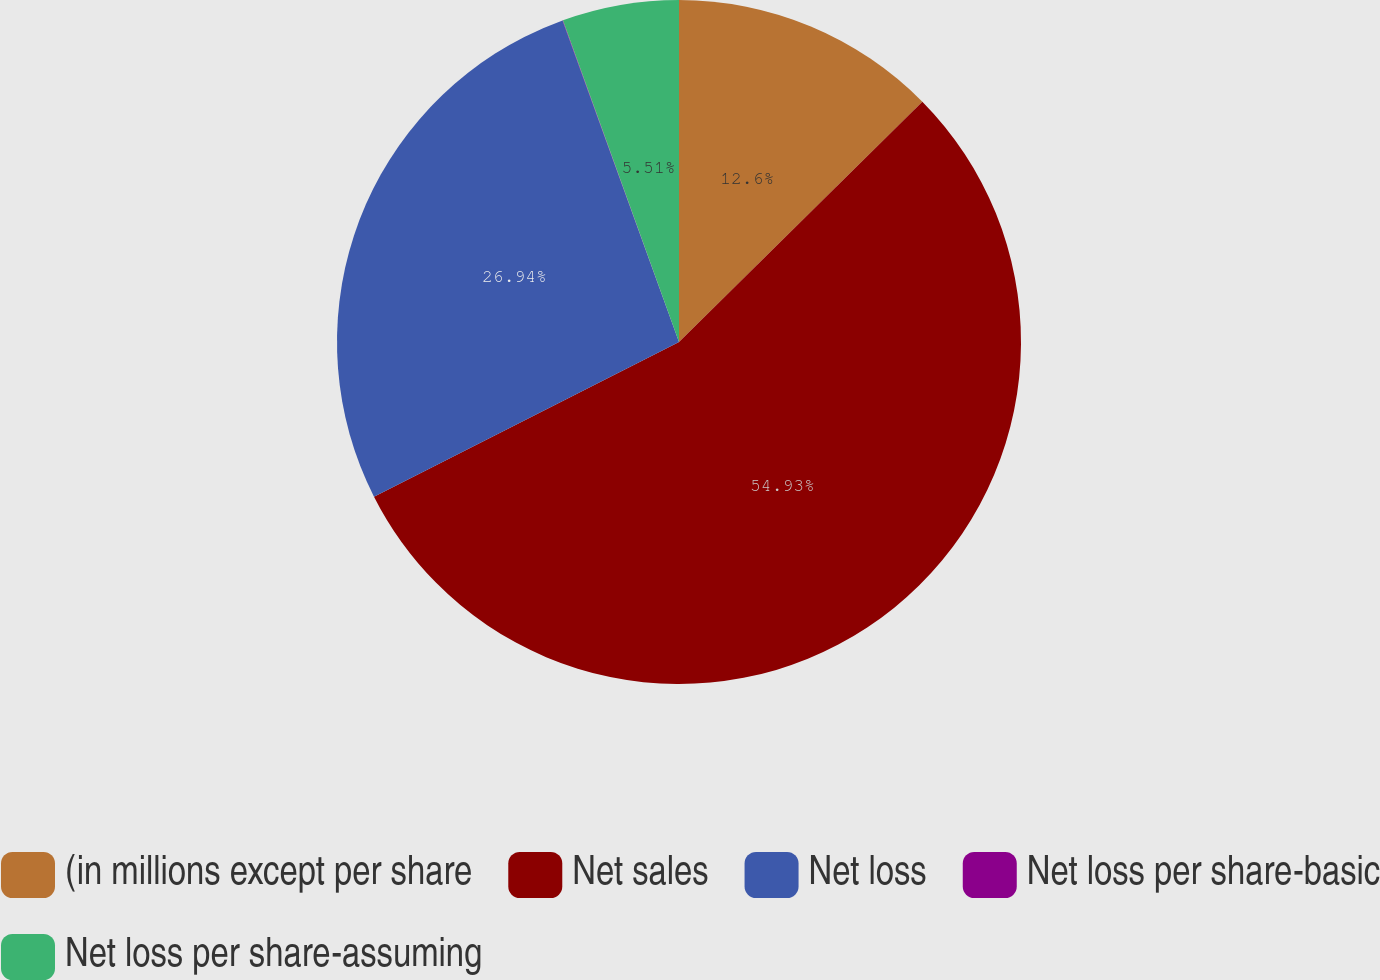Convert chart to OTSL. <chart><loc_0><loc_0><loc_500><loc_500><pie_chart><fcel>(in millions except per share<fcel>Net sales<fcel>Net loss<fcel>Net loss per share-basic<fcel>Net loss per share-assuming<nl><fcel>12.6%<fcel>54.93%<fcel>26.94%<fcel>0.02%<fcel>5.51%<nl></chart> 